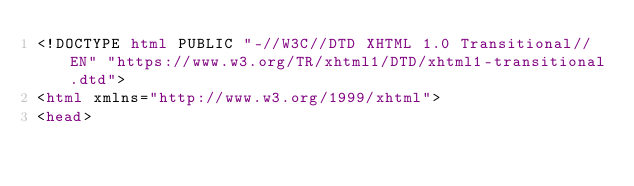<code> <loc_0><loc_0><loc_500><loc_500><_HTML_><!DOCTYPE html PUBLIC "-//W3C//DTD XHTML 1.0 Transitional//EN" "https://www.w3.org/TR/xhtml1/DTD/xhtml1-transitional.dtd">
<html xmlns="http://www.w3.org/1999/xhtml">
<head></code> 